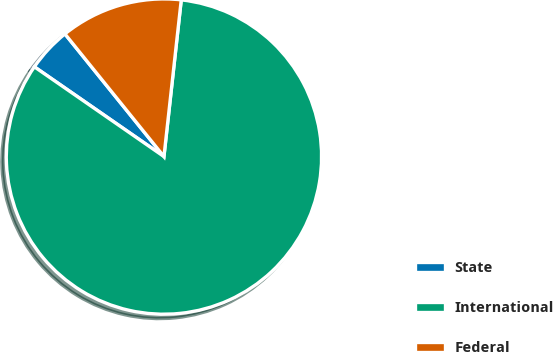Convert chart to OTSL. <chart><loc_0><loc_0><loc_500><loc_500><pie_chart><fcel>State<fcel>International<fcel>Federal<nl><fcel>4.55%<fcel>82.89%<fcel>12.56%<nl></chart> 